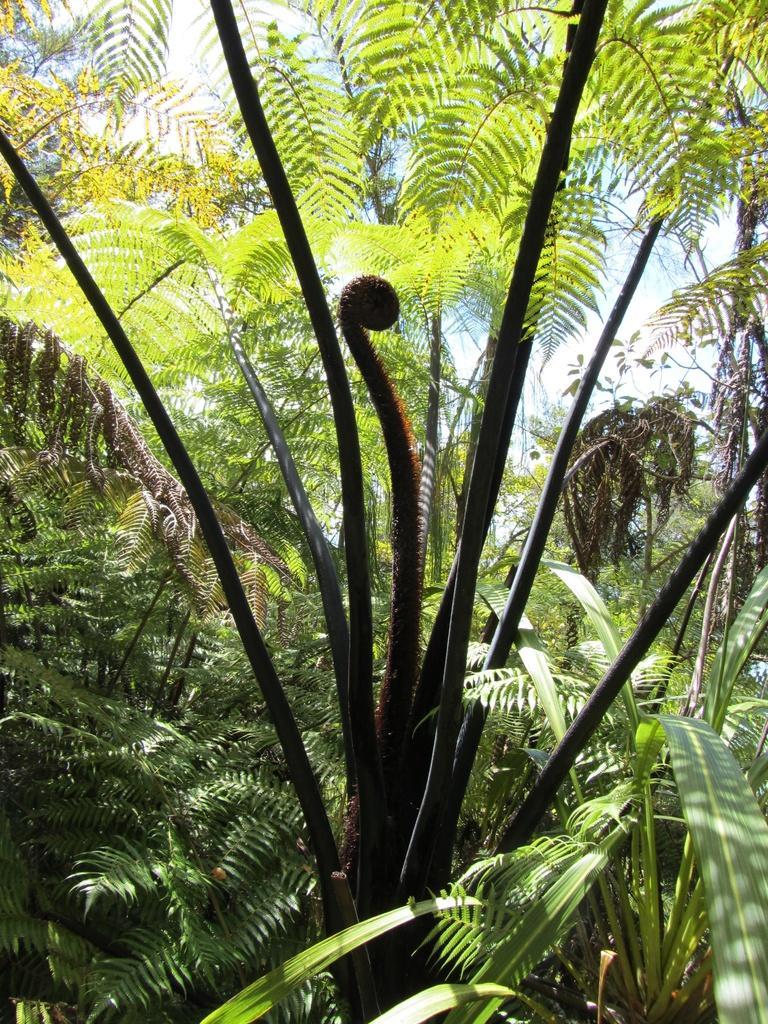In one or two sentences, can you explain what this image depicts? In the image we can see some trees. Behind the trees there are some clouds and sky. 